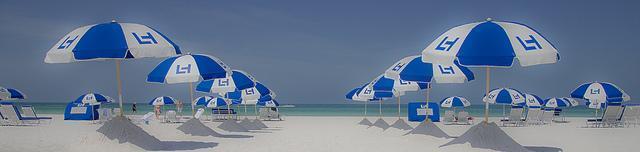How many umbrellas can be seen?
Give a very brief answer. 2. How many horses are pulling the cart?
Give a very brief answer. 0. 